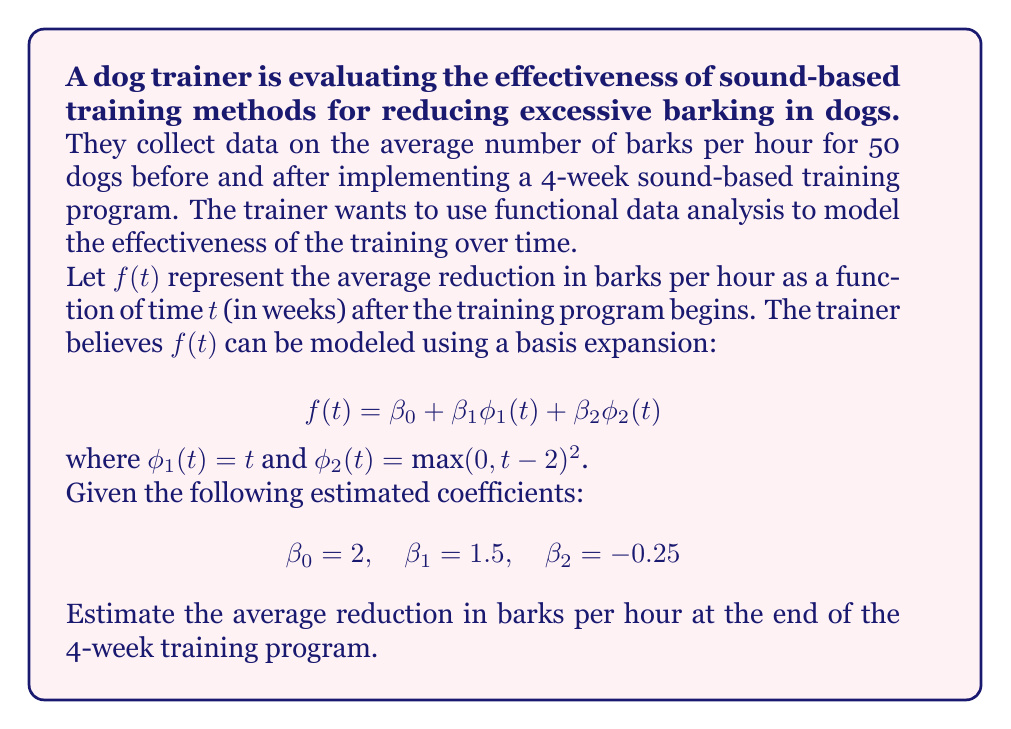Give your solution to this math problem. To solve this problem, we need to follow these steps:

1. Understand the given functional model:
   The function $f(t)$ represents the average reduction in barks per hour at time $t$ (in weeks).
   
2. Identify the basis functions and coefficients:
   $\phi_1(t) = t$
   $\phi_2(t) = \max(0, t-2)^2$
   $\beta_0 = 2$, $\beta_1 = 1.5$, $\beta_2 = -0.25$

3. Evaluate the function at $t = 4$ (end of the 4-week program):
   
   $f(4) = \beta_0 + \beta_1 \phi_1(4) + \beta_2 \phi_2(4)$
   
   First, calculate $\phi_1(4)$ and $\phi_2(4)$:
   
   $\phi_1(4) = 4$
   
   $\phi_2(4) = \max(0, 4-2)^2 = 2^2 = 4$

4. Substitute the values into the equation:

   $f(4) = 2 + 1.5(4) + (-0.25)(4)$
   
   $f(4) = 2 + 6 - 1$
   
   $f(4) = 7$

Therefore, at the end of the 4-week training program, the estimated average reduction in barks per hour is 7.
Answer: 7 barks per hour 